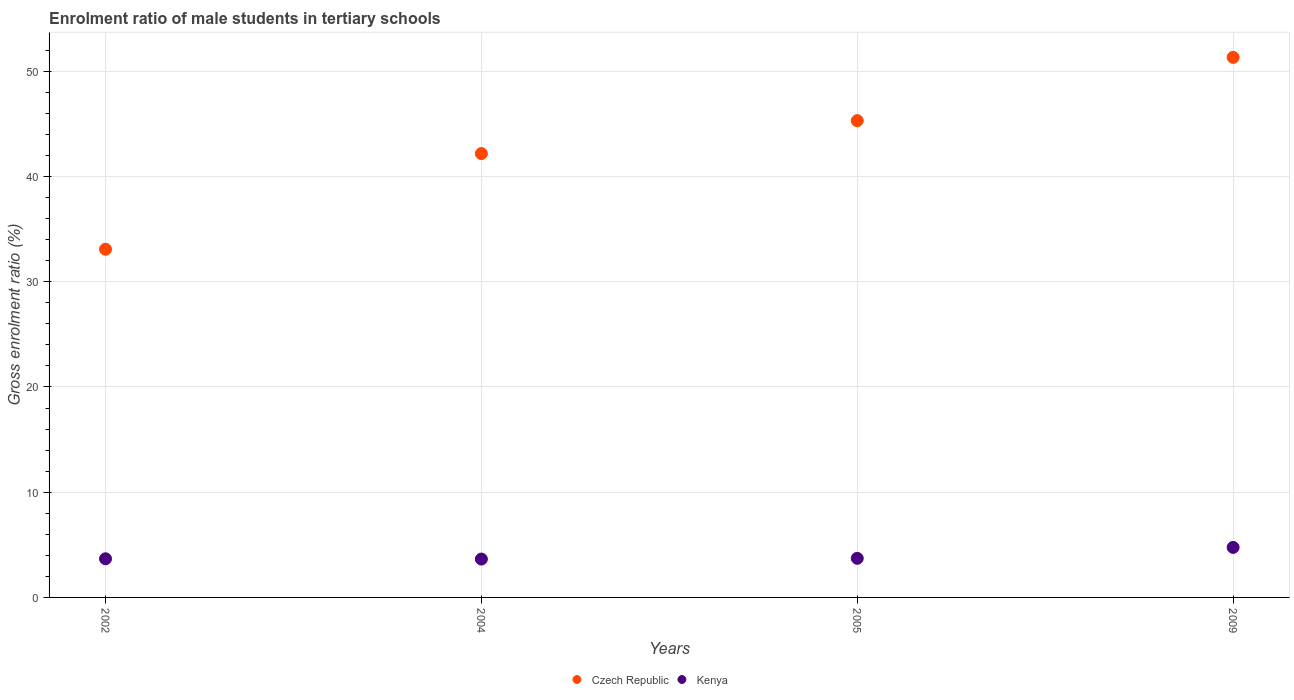What is the enrolment ratio of male students in tertiary schools in Kenya in 2002?
Offer a very short reply. 3.67. Across all years, what is the maximum enrolment ratio of male students in tertiary schools in Kenya?
Your answer should be very brief. 4.75. Across all years, what is the minimum enrolment ratio of male students in tertiary schools in Kenya?
Offer a very short reply. 3.65. What is the total enrolment ratio of male students in tertiary schools in Czech Republic in the graph?
Your response must be concise. 171.89. What is the difference between the enrolment ratio of male students in tertiary schools in Kenya in 2005 and that in 2009?
Provide a succinct answer. -1.04. What is the difference between the enrolment ratio of male students in tertiary schools in Kenya in 2002 and the enrolment ratio of male students in tertiary schools in Czech Republic in 2009?
Keep it short and to the point. -47.65. What is the average enrolment ratio of male students in tertiary schools in Kenya per year?
Keep it short and to the point. 3.95. In the year 2002, what is the difference between the enrolment ratio of male students in tertiary schools in Czech Republic and enrolment ratio of male students in tertiary schools in Kenya?
Your answer should be very brief. 29.42. What is the ratio of the enrolment ratio of male students in tertiary schools in Kenya in 2002 to that in 2009?
Your answer should be very brief. 0.77. What is the difference between the highest and the second highest enrolment ratio of male students in tertiary schools in Kenya?
Ensure brevity in your answer.  1.04. What is the difference between the highest and the lowest enrolment ratio of male students in tertiary schools in Kenya?
Offer a very short reply. 1.11. In how many years, is the enrolment ratio of male students in tertiary schools in Kenya greater than the average enrolment ratio of male students in tertiary schools in Kenya taken over all years?
Offer a terse response. 1. Is the sum of the enrolment ratio of male students in tertiary schools in Czech Republic in 2005 and 2009 greater than the maximum enrolment ratio of male students in tertiary schools in Kenya across all years?
Offer a very short reply. Yes. Does the enrolment ratio of male students in tertiary schools in Czech Republic monotonically increase over the years?
Ensure brevity in your answer.  Yes. Is the enrolment ratio of male students in tertiary schools in Czech Republic strictly greater than the enrolment ratio of male students in tertiary schools in Kenya over the years?
Your answer should be compact. Yes. How many dotlines are there?
Make the answer very short. 2. How many years are there in the graph?
Your answer should be compact. 4. Does the graph contain any zero values?
Offer a very short reply. No. How are the legend labels stacked?
Your response must be concise. Horizontal. What is the title of the graph?
Give a very brief answer. Enrolment ratio of male students in tertiary schools. What is the label or title of the Y-axis?
Your answer should be very brief. Gross enrolment ratio (%). What is the Gross enrolment ratio (%) in Czech Republic in 2002?
Offer a terse response. 33.09. What is the Gross enrolment ratio (%) of Kenya in 2002?
Provide a succinct answer. 3.67. What is the Gross enrolment ratio (%) in Czech Republic in 2004?
Offer a terse response. 42.18. What is the Gross enrolment ratio (%) in Kenya in 2004?
Offer a very short reply. 3.65. What is the Gross enrolment ratio (%) of Czech Republic in 2005?
Ensure brevity in your answer.  45.3. What is the Gross enrolment ratio (%) in Kenya in 2005?
Your answer should be very brief. 3.72. What is the Gross enrolment ratio (%) of Czech Republic in 2009?
Keep it short and to the point. 51.32. What is the Gross enrolment ratio (%) of Kenya in 2009?
Provide a short and direct response. 4.75. Across all years, what is the maximum Gross enrolment ratio (%) in Czech Republic?
Make the answer very short. 51.32. Across all years, what is the maximum Gross enrolment ratio (%) in Kenya?
Give a very brief answer. 4.75. Across all years, what is the minimum Gross enrolment ratio (%) in Czech Republic?
Offer a very short reply. 33.09. Across all years, what is the minimum Gross enrolment ratio (%) of Kenya?
Your response must be concise. 3.65. What is the total Gross enrolment ratio (%) of Czech Republic in the graph?
Offer a terse response. 171.89. What is the total Gross enrolment ratio (%) of Kenya in the graph?
Give a very brief answer. 15.79. What is the difference between the Gross enrolment ratio (%) in Czech Republic in 2002 and that in 2004?
Keep it short and to the point. -9.09. What is the difference between the Gross enrolment ratio (%) of Kenya in 2002 and that in 2004?
Provide a short and direct response. 0.03. What is the difference between the Gross enrolment ratio (%) in Czech Republic in 2002 and that in 2005?
Your answer should be compact. -12.22. What is the difference between the Gross enrolment ratio (%) in Kenya in 2002 and that in 2005?
Make the answer very short. -0.04. What is the difference between the Gross enrolment ratio (%) in Czech Republic in 2002 and that in 2009?
Your answer should be very brief. -18.23. What is the difference between the Gross enrolment ratio (%) of Kenya in 2002 and that in 2009?
Give a very brief answer. -1.08. What is the difference between the Gross enrolment ratio (%) in Czech Republic in 2004 and that in 2005?
Your answer should be compact. -3.13. What is the difference between the Gross enrolment ratio (%) of Kenya in 2004 and that in 2005?
Provide a short and direct response. -0.07. What is the difference between the Gross enrolment ratio (%) of Czech Republic in 2004 and that in 2009?
Give a very brief answer. -9.14. What is the difference between the Gross enrolment ratio (%) in Kenya in 2004 and that in 2009?
Make the answer very short. -1.11. What is the difference between the Gross enrolment ratio (%) of Czech Republic in 2005 and that in 2009?
Offer a very short reply. -6.02. What is the difference between the Gross enrolment ratio (%) in Kenya in 2005 and that in 2009?
Ensure brevity in your answer.  -1.04. What is the difference between the Gross enrolment ratio (%) in Czech Republic in 2002 and the Gross enrolment ratio (%) in Kenya in 2004?
Your response must be concise. 29.44. What is the difference between the Gross enrolment ratio (%) of Czech Republic in 2002 and the Gross enrolment ratio (%) of Kenya in 2005?
Give a very brief answer. 29.37. What is the difference between the Gross enrolment ratio (%) in Czech Republic in 2002 and the Gross enrolment ratio (%) in Kenya in 2009?
Ensure brevity in your answer.  28.34. What is the difference between the Gross enrolment ratio (%) of Czech Republic in 2004 and the Gross enrolment ratio (%) of Kenya in 2005?
Provide a succinct answer. 38.46. What is the difference between the Gross enrolment ratio (%) in Czech Republic in 2004 and the Gross enrolment ratio (%) in Kenya in 2009?
Give a very brief answer. 37.42. What is the difference between the Gross enrolment ratio (%) in Czech Republic in 2005 and the Gross enrolment ratio (%) in Kenya in 2009?
Make the answer very short. 40.55. What is the average Gross enrolment ratio (%) of Czech Republic per year?
Keep it short and to the point. 42.97. What is the average Gross enrolment ratio (%) in Kenya per year?
Provide a succinct answer. 3.95. In the year 2002, what is the difference between the Gross enrolment ratio (%) in Czech Republic and Gross enrolment ratio (%) in Kenya?
Your answer should be compact. 29.42. In the year 2004, what is the difference between the Gross enrolment ratio (%) of Czech Republic and Gross enrolment ratio (%) of Kenya?
Make the answer very short. 38.53. In the year 2005, what is the difference between the Gross enrolment ratio (%) of Czech Republic and Gross enrolment ratio (%) of Kenya?
Give a very brief answer. 41.59. In the year 2009, what is the difference between the Gross enrolment ratio (%) in Czech Republic and Gross enrolment ratio (%) in Kenya?
Keep it short and to the point. 46.57. What is the ratio of the Gross enrolment ratio (%) of Czech Republic in 2002 to that in 2004?
Provide a short and direct response. 0.78. What is the ratio of the Gross enrolment ratio (%) in Kenya in 2002 to that in 2004?
Offer a very short reply. 1.01. What is the ratio of the Gross enrolment ratio (%) in Czech Republic in 2002 to that in 2005?
Keep it short and to the point. 0.73. What is the ratio of the Gross enrolment ratio (%) in Czech Republic in 2002 to that in 2009?
Keep it short and to the point. 0.64. What is the ratio of the Gross enrolment ratio (%) of Kenya in 2002 to that in 2009?
Offer a terse response. 0.77. What is the ratio of the Gross enrolment ratio (%) in Czech Republic in 2004 to that in 2005?
Ensure brevity in your answer.  0.93. What is the ratio of the Gross enrolment ratio (%) in Kenya in 2004 to that in 2005?
Ensure brevity in your answer.  0.98. What is the ratio of the Gross enrolment ratio (%) of Czech Republic in 2004 to that in 2009?
Your response must be concise. 0.82. What is the ratio of the Gross enrolment ratio (%) in Kenya in 2004 to that in 2009?
Keep it short and to the point. 0.77. What is the ratio of the Gross enrolment ratio (%) of Czech Republic in 2005 to that in 2009?
Make the answer very short. 0.88. What is the ratio of the Gross enrolment ratio (%) of Kenya in 2005 to that in 2009?
Provide a short and direct response. 0.78. What is the difference between the highest and the second highest Gross enrolment ratio (%) in Czech Republic?
Your answer should be very brief. 6.02. What is the difference between the highest and the second highest Gross enrolment ratio (%) in Kenya?
Your answer should be compact. 1.04. What is the difference between the highest and the lowest Gross enrolment ratio (%) in Czech Republic?
Give a very brief answer. 18.23. What is the difference between the highest and the lowest Gross enrolment ratio (%) in Kenya?
Ensure brevity in your answer.  1.11. 